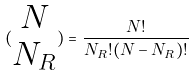<formula> <loc_0><loc_0><loc_500><loc_500>( \begin{matrix} N \\ N _ { R } \end{matrix} ) = \frac { N ! } { N _ { R } ! ( N - N _ { R } ) ! }</formula> 